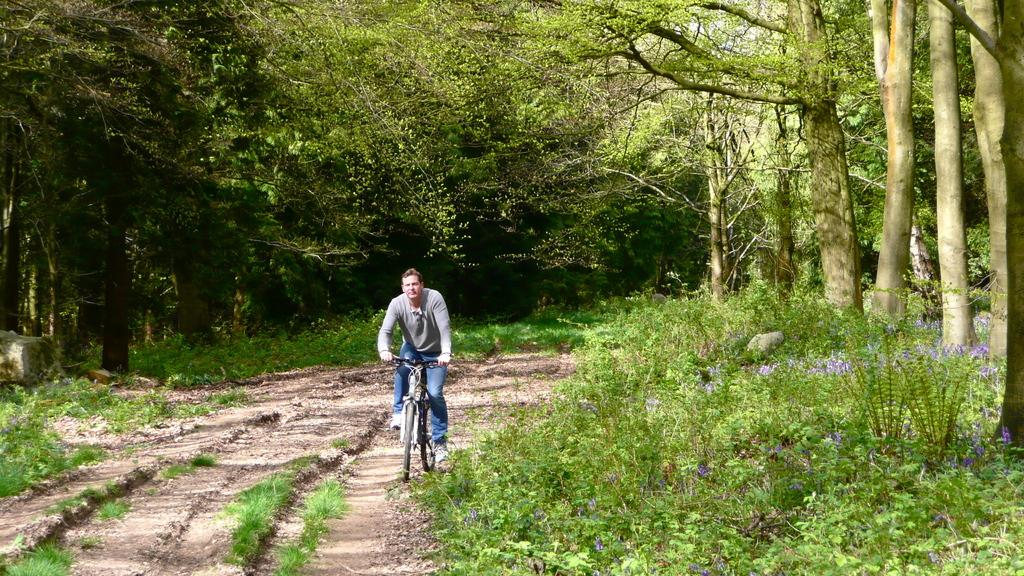What is the main subject of the image? There is a man in the image. What is the man doing in the image? The man is riding a bicycle. What can be seen in the background of the image? There are trees in the background of the image. What type of vegetation is present can be seen on the ground in the image? There are plants on the ground in the image. What type of chair is the man sitting on while riding the bicycle in the image? There is no chair present in the image; the man is riding a bicycle without a chair. Is there a volcano visible in the image? No, there is no volcano present in the image. 